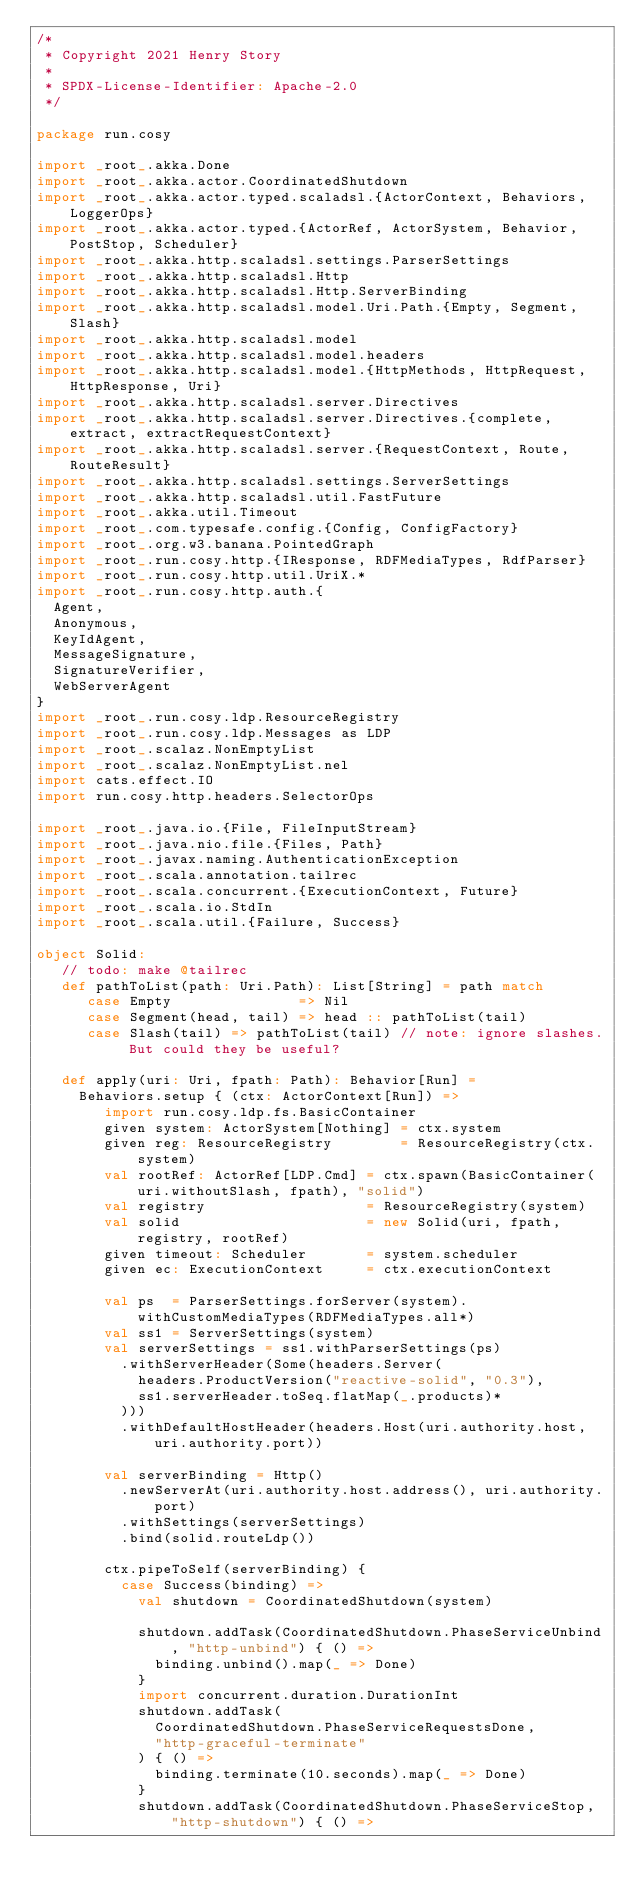Convert code to text. <code><loc_0><loc_0><loc_500><loc_500><_Scala_>/*
 * Copyright 2021 Henry Story
 *
 * SPDX-License-Identifier: Apache-2.0
 */

package run.cosy

import _root_.akka.Done
import _root_.akka.actor.CoordinatedShutdown
import _root_.akka.actor.typed.scaladsl.{ActorContext, Behaviors, LoggerOps}
import _root_.akka.actor.typed.{ActorRef, ActorSystem, Behavior, PostStop, Scheduler}
import _root_.akka.http.scaladsl.settings.ParserSettings
import _root_.akka.http.scaladsl.Http
import _root_.akka.http.scaladsl.Http.ServerBinding
import _root_.akka.http.scaladsl.model.Uri.Path.{Empty, Segment, Slash}
import _root_.akka.http.scaladsl.model
import _root_.akka.http.scaladsl.model.headers
import _root_.akka.http.scaladsl.model.{HttpMethods, HttpRequest, HttpResponse, Uri}
import _root_.akka.http.scaladsl.server.Directives
import _root_.akka.http.scaladsl.server.Directives.{complete, extract, extractRequestContext}
import _root_.akka.http.scaladsl.server.{RequestContext, Route, RouteResult}
import _root_.akka.http.scaladsl.settings.ServerSettings
import _root_.akka.http.scaladsl.util.FastFuture
import _root_.akka.util.Timeout
import _root_.com.typesafe.config.{Config, ConfigFactory}
import _root_.org.w3.banana.PointedGraph
import _root_.run.cosy.http.{IResponse, RDFMediaTypes, RdfParser}
import _root_.run.cosy.http.util.UriX.*
import _root_.run.cosy.http.auth.{
  Agent,
  Anonymous,
  KeyIdAgent,
  MessageSignature,
  SignatureVerifier,
  WebServerAgent
}
import _root_.run.cosy.ldp.ResourceRegistry
import _root_.run.cosy.ldp.Messages as LDP
import _root_.scalaz.NonEmptyList
import _root_.scalaz.NonEmptyList.nel
import cats.effect.IO
import run.cosy.http.headers.SelectorOps

import _root_.java.io.{File, FileInputStream}
import _root_.java.nio.file.{Files, Path}
import _root_.javax.naming.AuthenticationException
import _root_.scala.annotation.tailrec
import _root_.scala.concurrent.{ExecutionContext, Future}
import _root_.scala.io.StdIn
import _root_.scala.util.{Failure, Success}

object Solid:
   // todo: make @tailrec
   def pathToList(path: Uri.Path): List[String] = path match
      case Empty               => Nil
      case Segment(head, tail) => head :: pathToList(tail)
      case Slash(tail) => pathToList(tail) // note: ignore slashes. But could they be useful?

   def apply(uri: Uri, fpath: Path): Behavior[Run] =
     Behaviors.setup { (ctx: ActorContext[Run]) =>
        import run.cosy.ldp.fs.BasicContainer
        given system: ActorSystem[Nothing] = ctx.system
        given reg: ResourceRegistry        = ResourceRegistry(ctx.system)
        val rootRef: ActorRef[LDP.Cmd] = ctx.spawn(BasicContainer(uri.withoutSlash, fpath), "solid")
        val registry                   = ResourceRegistry(system)
        val solid                      = new Solid(uri, fpath, registry, rootRef)
        given timeout: Scheduler       = system.scheduler
        given ec: ExecutionContext     = ctx.executionContext

        val ps  = ParserSettings.forServer(system).withCustomMediaTypes(RDFMediaTypes.all*)
        val ss1 = ServerSettings(system)
        val serverSettings = ss1.withParserSettings(ps)
          .withServerHeader(Some(headers.Server(
            headers.ProductVersion("reactive-solid", "0.3"),
            ss1.serverHeader.toSeq.flatMap(_.products)*
          )))
          .withDefaultHostHeader(headers.Host(uri.authority.host, uri.authority.port))

        val serverBinding = Http()
          .newServerAt(uri.authority.host.address(), uri.authority.port)
          .withSettings(serverSettings)
          .bind(solid.routeLdp())

        ctx.pipeToSelf(serverBinding) {
          case Success(binding) =>
            val shutdown = CoordinatedShutdown(system)

            shutdown.addTask(CoordinatedShutdown.PhaseServiceUnbind, "http-unbind") { () =>
              binding.unbind().map(_ => Done)
            }
            import concurrent.duration.DurationInt
            shutdown.addTask(
              CoordinatedShutdown.PhaseServiceRequestsDone,
              "http-graceful-terminate"
            ) { () =>
              binding.terminate(10.seconds).map(_ => Done)
            }
            shutdown.addTask(CoordinatedShutdown.PhaseServiceStop, "http-shutdown") { () =></code> 